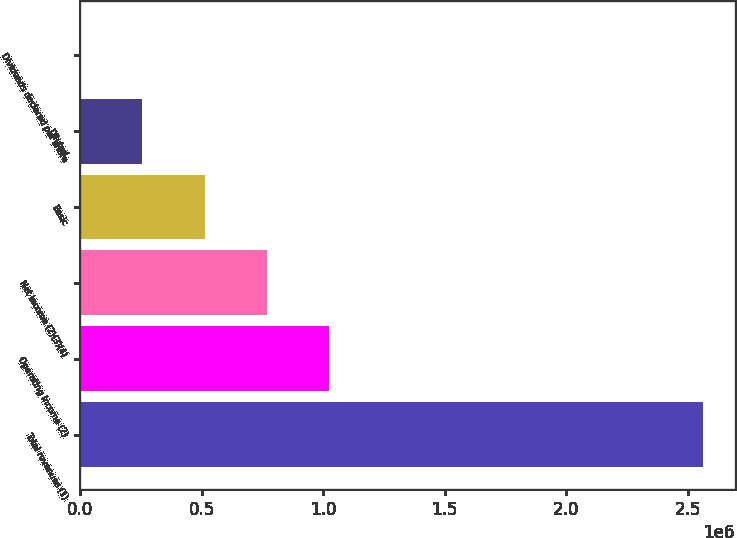Convert chart to OTSL. <chart><loc_0><loc_0><loc_500><loc_500><bar_chart><fcel>Total revenues (1)<fcel>Operating income (2)<fcel>Net income (2)(3)(4)<fcel>Basic<fcel>Diluted<fcel>Dividends declared per share<nl><fcel>2.56374e+06<fcel>1.0255e+06<fcel>769123<fcel>512749<fcel>256375<fcel>0.48<nl></chart> 